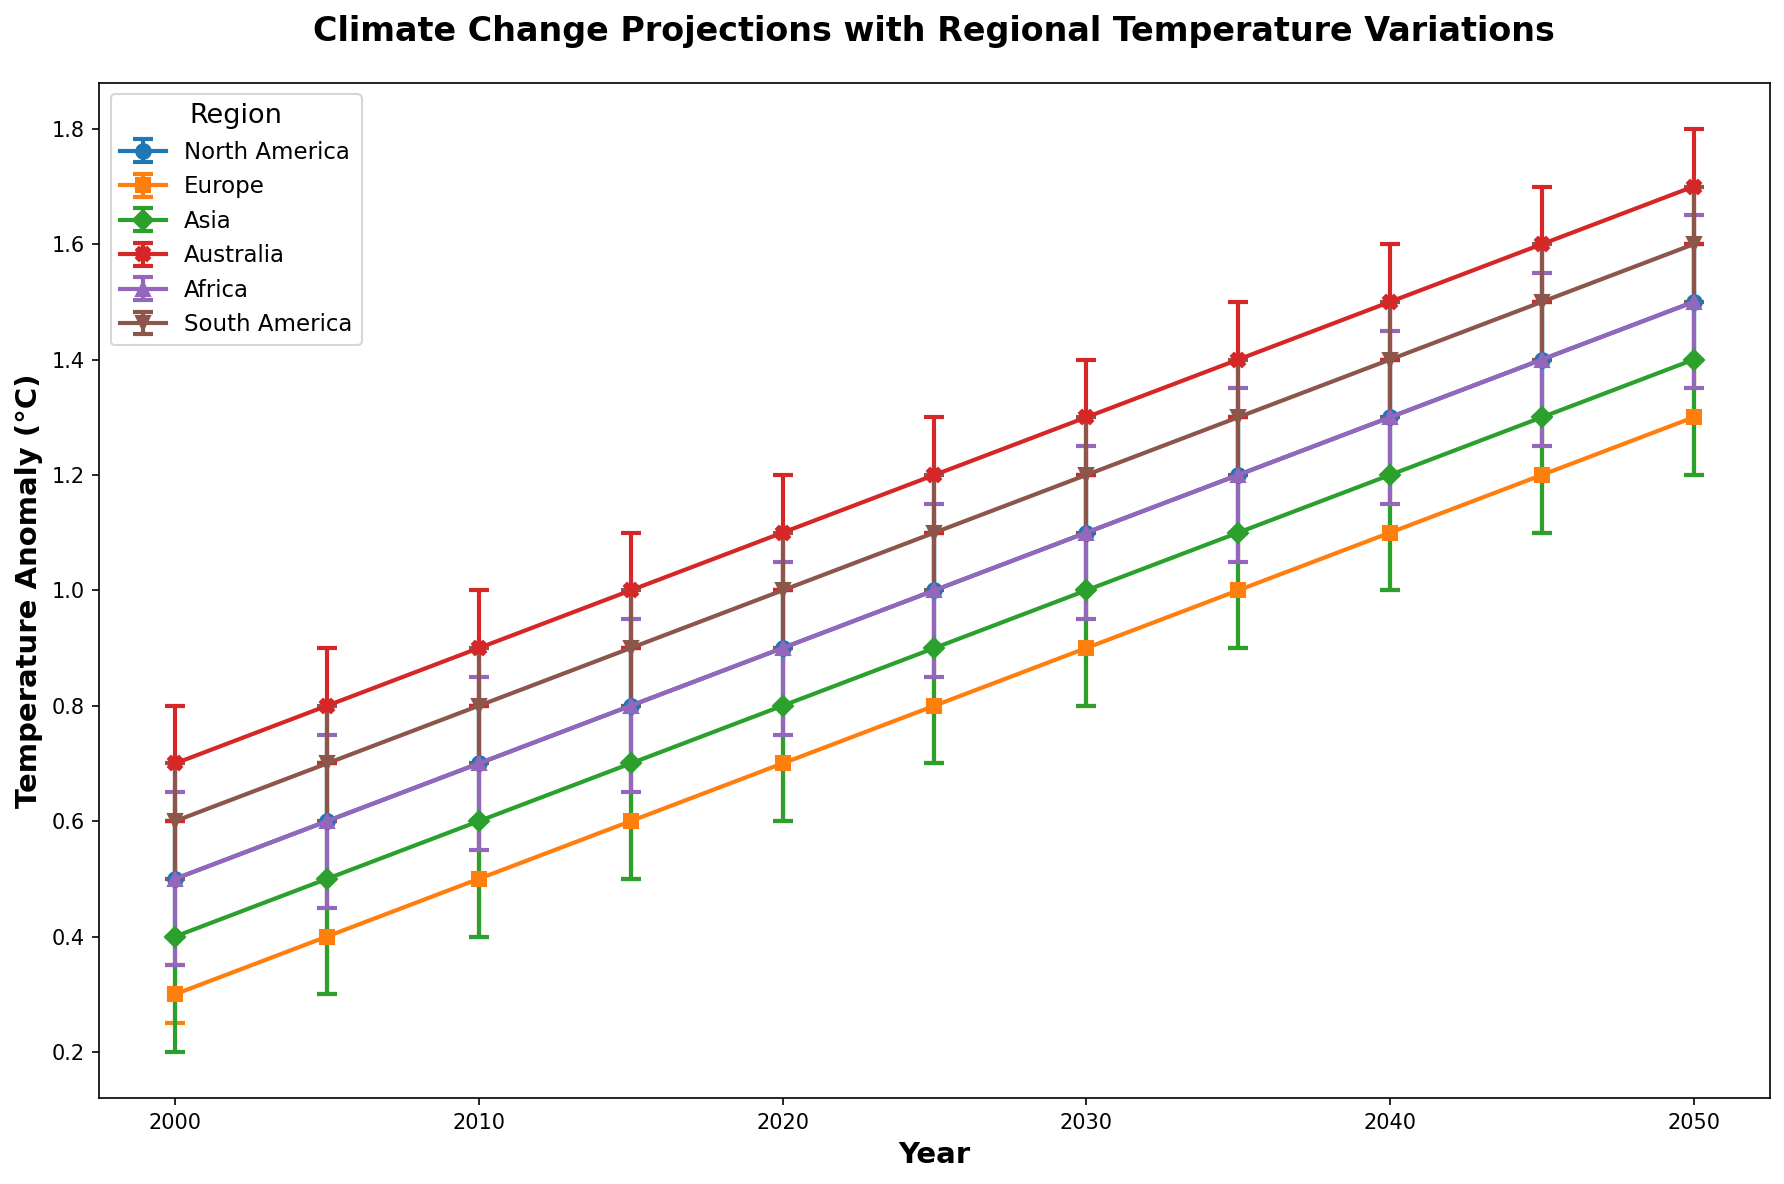Which region shows the highest temperature anomaly in 2050? In 2050, we observe the temperature anomalies for each region and determine that Africa has the highest temperature anomaly of 1.5°C.
Answer: Africa Which region has the least temperature anomaly in 2035, and what is it? By checking temperature anomaly values in 2035, Europe has the least anomaly with 1.0°C.
Answer: Europe, 1.0°C How many degrees did Australia’s temperature anomaly increase from 2000 to 2020? Australia's temperature anomaly in 2000 was 0.7°C, and in 2020 it was 1.1°C. Therefore, the increase is 1.1 - 0.7 = 0.4°C.
Answer: 0.4°C Compare the temperature anomalies between Europe and Asia for the year 2010; which one is higher? Europe has a temperature anomaly of 0.5°C, while Asia has 0.6°C in 2010; hence, Asia’s anomaly is higher.
Answer: Asia Calculate the average temperature anomaly for South America from 2000 to 2050. To find the average, add South America's anomalies from 2000 (0.6), 2005 (0.7), 2010 (0.8), 2015 (0.9), 2020 (1.0), 2025 (1.1), 2030 (1.2), 2035 (1.3), 2040 (1.4), 2045 (1.5), and 2050 (1.6). Then divide the sum by 11: 
(0.6 + 0.7 + 0.8 + 0.9 + 1.0 + 1.1 + 1.2 + 1.3 + 1.4 + 1.5 + 1.6)/11 = 1.09°C.
Answer: 1.09°C Which region shows the most significant variation (difference between highest and lowest anomaly) over the observed years? To determine the greatest variation, calculate the difference between the highest and lowest temperature anomalies for each region. The calculations reveal that Australia has the most significant variation, with a difference of 1.7 - 0.7 = 1.0°C.
Answer: Australia What are the error ranges for Africa and Europe in 2045, and which region has a wider range? In 2045, Africa’s error range is 0.15, and Europe’s error range is 0.1. Therefore, Africa has the wider error range.
Answer: Africa Describe the trend in temperature anomaly for North America from 2000 to 2050. Observing North America's values from 2000 to 2050 shows a steady increase: 0.5, 0.6, 0.7, 0.8, 0.9, 1.0, 1.1, 1.2, 1.3, 1.4, 1.5, indicating a rising trend over the years.
Answer: Increasing trend 